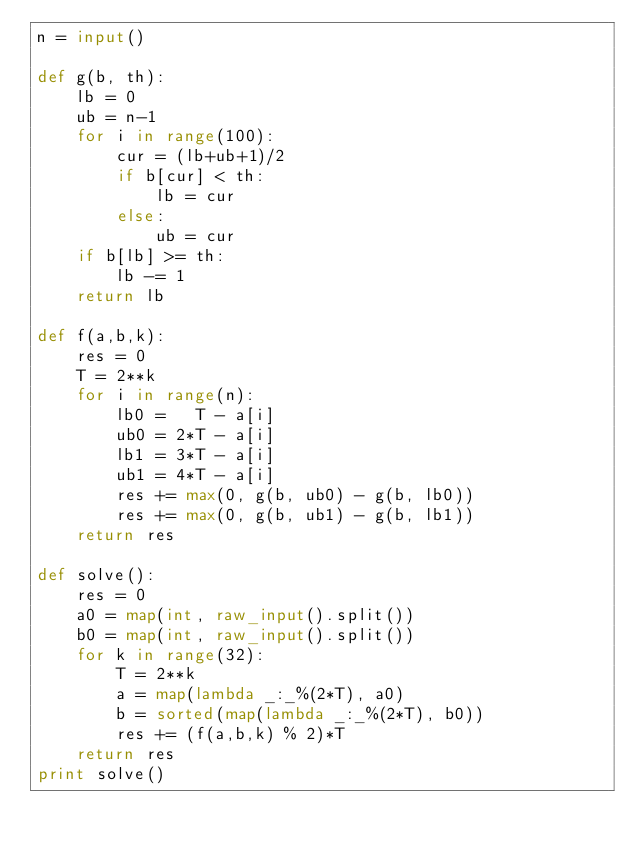<code> <loc_0><loc_0><loc_500><loc_500><_Python_>n = input()

def g(b, th):
    lb = 0
    ub = n-1
    for i in range(100):
        cur = (lb+ub+1)/2
        if b[cur] < th:
            lb = cur
        else:
            ub = cur
    if b[lb] >= th:
        lb -= 1
    return lb

def f(a,b,k):
    res = 0
    T = 2**k
    for i in range(n):
        lb0 =   T - a[i]
        ub0 = 2*T - a[i]
        lb1 = 3*T - a[i]
        ub1 = 4*T - a[i]
        res += max(0, g(b, ub0) - g(b, lb0))
        res += max(0, g(b, ub1) - g(b, lb1))
    return res

def solve():
    res = 0
    a0 = map(int, raw_input().split())
    b0 = map(int, raw_input().split())
    for k in range(32):
        T = 2**k
        a = map(lambda _:_%(2*T), a0)
        b = sorted(map(lambda _:_%(2*T), b0))
        res += (f(a,b,k) % 2)*T
    return res
print solve()</code> 